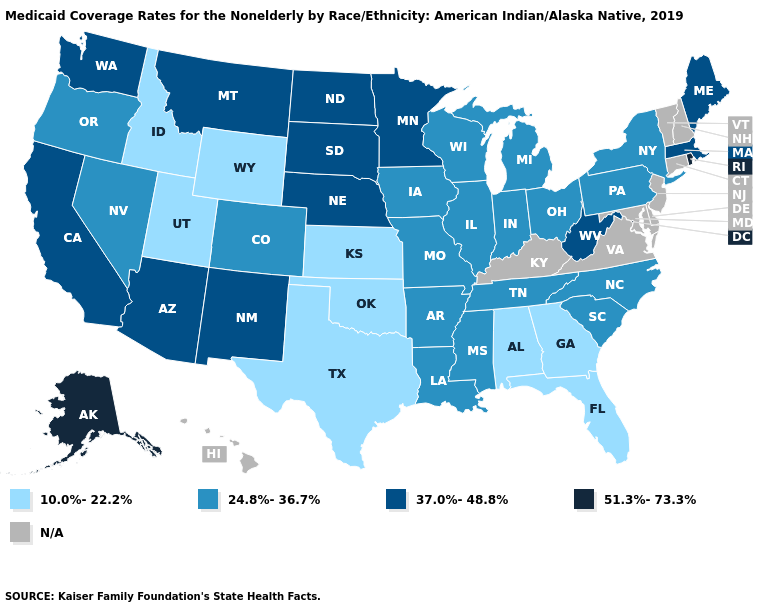Does Minnesota have the lowest value in the USA?
Give a very brief answer. No. What is the value of Michigan?
Give a very brief answer. 24.8%-36.7%. Name the states that have a value in the range 37.0%-48.8%?
Be succinct. Arizona, California, Maine, Massachusetts, Minnesota, Montana, Nebraska, New Mexico, North Dakota, South Dakota, Washington, West Virginia. Among the states that border South Dakota , does Montana have the highest value?
Short answer required. Yes. What is the lowest value in the MidWest?
Quick response, please. 10.0%-22.2%. Name the states that have a value in the range 10.0%-22.2%?
Give a very brief answer. Alabama, Florida, Georgia, Idaho, Kansas, Oklahoma, Texas, Utah, Wyoming. Which states have the lowest value in the USA?
Give a very brief answer. Alabama, Florida, Georgia, Idaho, Kansas, Oklahoma, Texas, Utah, Wyoming. Does Utah have the highest value in the USA?
Give a very brief answer. No. What is the value of Utah?
Quick response, please. 10.0%-22.2%. Does the first symbol in the legend represent the smallest category?
Concise answer only. Yes. Name the states that have a value in the range 51.3%-73.3%?
Answer briefly. Alaska, Rhode Island. What is the value of Indiana?
Short answer required. 24.8%-36.7%. What is the highest value in states that border Florida?
Answer briefly. 10.0%-22.2%. What is the value of South Dakota?
Answer briefly. 37.0%-48.8%. Is the legend a continuous bar?
Write a very short answer. No. 